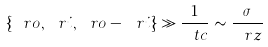Convert formula to latex. <formula><loc_0><loc_0><loc_500><loc_500>\{ \ r o , \ r i , \ r o - \ r i \} \gg \frac { 1 } { \ t c } \sim \frac { \sigma } { \ r z }</formula> 